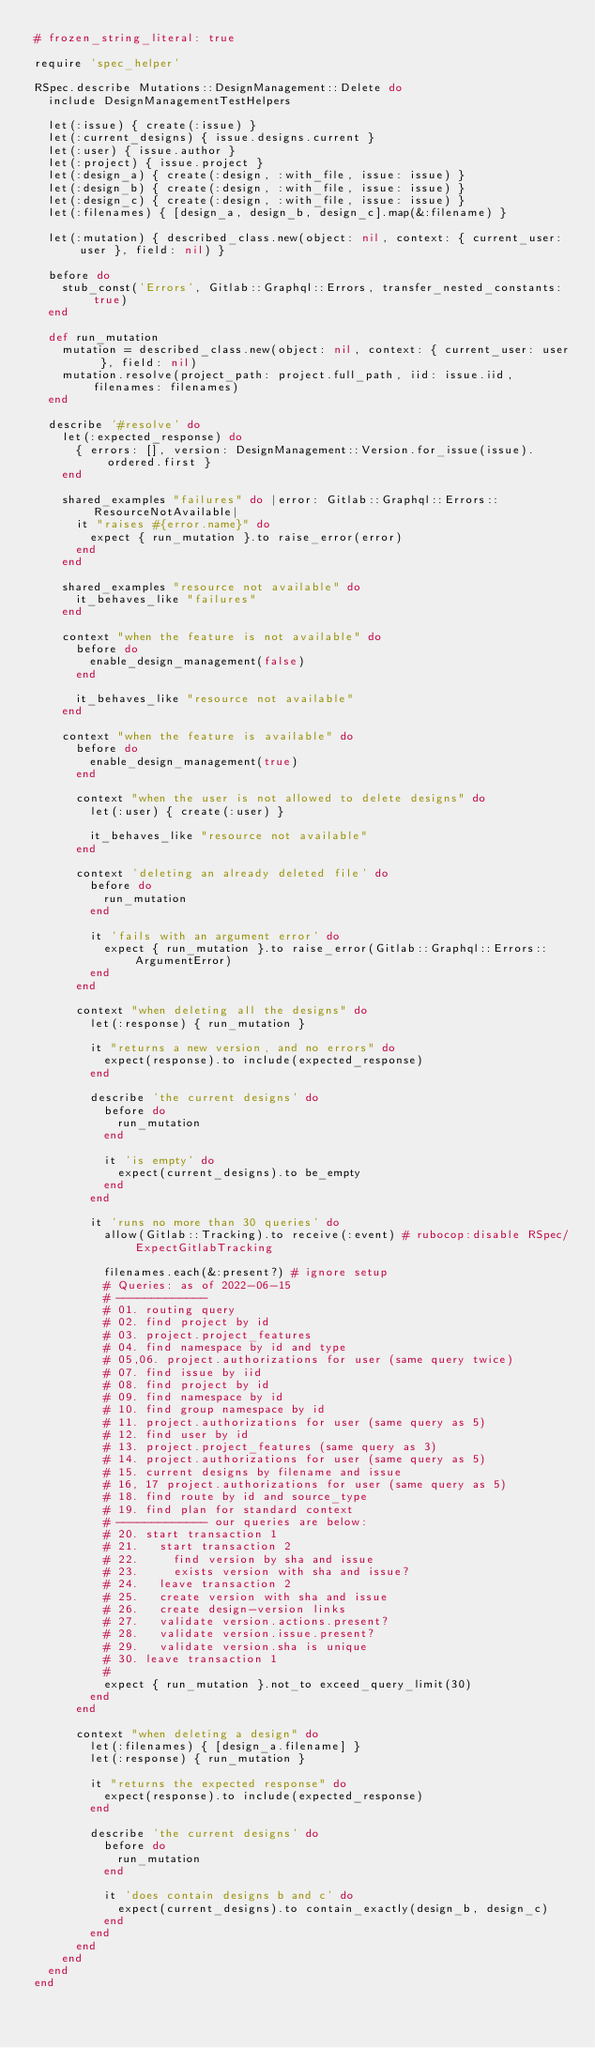Convert code to text. <code><loc_0><loc_0><loc_500><loc_500><_Ruby_># frozen_string_literal: true

require 'spec_helper'

RSpec.describe Mutations::DesignManagement::Delete do
  include DesignManagementTestHelpers

  let(:issue) { create(:issue) }
  let(:current_designs) { issue.designs.current }
  let(:user) { issue.author }
  let(:project) { issue.project }
  let(:design_a) { create(:design, :with_file, issue: issue) }
  let(:design_b) { create(:design, :with_file, issue: issue) }
  let(:design_c) { create(:design, :with_file, issue: issue) }
  let(:filenames) { [design_a, design_b, design_c].map(&:filename) }

  let(:mutation) { described_class.new(object: nil, context: { current_user: user }, field: nil) }

  before do
    stub_const('Errors', Gitlab::Graphql::Errors, transfer_nested_constants: true)
  end

  def run_mutation
    mutation = described_class.new(object: nil, context: { current_user: user }, field: nil)
    mutation.resolve(project_path: project.full_path, iid: issue.iid, filenames: filenames)
  end

  describe '#resolve' do
    let(:expected_response) do
      { errors: [], version: DesignManagement::Version.for_issue(issue).ordered.first }
    end

    shared_examples "failures" do |error: Gitlab::Graphql::Errors::ResourceNotAvailable|
      it "raises #{error.name}" do
        expect { run_mutation }.to raise_error(error)
      end
    end

    shared_examples "resource not available" do
      it_behaves_like "failures"
    end

    context "when the feature is not available" do
      before do
        enable_design_management(false)
      end

      it_behaves_like "resource not available"
    end

    context "when the feature is available" do
      before do
        enable_design_management(true)
      end

      context "when the user is not allowed to delete designs" do
        let(:user) { create(:user) }

        it_behaves_like "resource not available"
      end

      context 'deleting an already deleted file' do
        before do
          run_mutation
        end

        it 'fails with an argument error' do
          expect { run_mutation }.to raise_error(Gitlab::Graphql::Errors::ArgumentError)
        end
      end

      context "when deleting all the designs" do
        let(:response) { run_mutation }

        it "returns a new version, and no errors" do
          expect(response).to include(expected_response)
        end

        describe 'the current designs' do
          before do
            run_mutation
          end

          it 'is empty' do
            expect(current_designs).to be_empty
          end
        end

        it 'runs no more than 30 queries' do
          allow(Gitlab::Tracking).to receive(:event) # rubocop:disable RSpec/ExpectGitlabTracking

          filenames.each(&:present?) # ignore setup
          # Queries: as of 2022-06-15
          # -------------
          # 01. routing query
          # 02. find project by id
          # 03. project.project_features
          # 04. find namespace by id and type
          # 05,06. project.authorizations for user (same query twice)
          # 07. find issue by iid
          # 08. find project by id
          # 09. find namespace by id
          # 10. find group namespace by id
          # 11. project.authorizations for user (same query as 5)
          # 12. find user by id
          # 13. project.project_features (same query as 3)
          # 14. project.authorizations for user (same query as 5)
          # 15. current designs by filename and issue
          # 16, 17 project.authorizations for user (same query as 5)
          # 18. find route by id and source_type
          # 19. find plan for standard context
          # ------------- our queries are below:
          # 20. start transaction 1
          # 21.   start transaction 2
          # 22.     find version by sha and issue
          # 23.     exists version with sha and issue?
          # 24.   leave transaction 2
          # 25.   create version with sha and issue
          # 26.   create design-version links
          # 27.   validate version.actions.present?
          # 28.   validate version.issue.present?
          # 29.   validate version.sha is unique
          # 30. leave transaction 1
          #
          expect { run_mutation }.not_to exceed_query_limit(30)
        end
      end

      context "when deleting a design" do
        let(:filenames) { [design_a.filename] }
        let(:response) { run_mutation }

        it "returns the expected response" do
          expect(response).to include(expected_response)
        end

        describe 'the current designs' do
          before do
            run_mutation
          end

          it 'does contain designs b and c' do
            expect(current_designs).to contain_exactly(design_b, design_c)
          end
        end
      end
    end
  end
end
</code> 